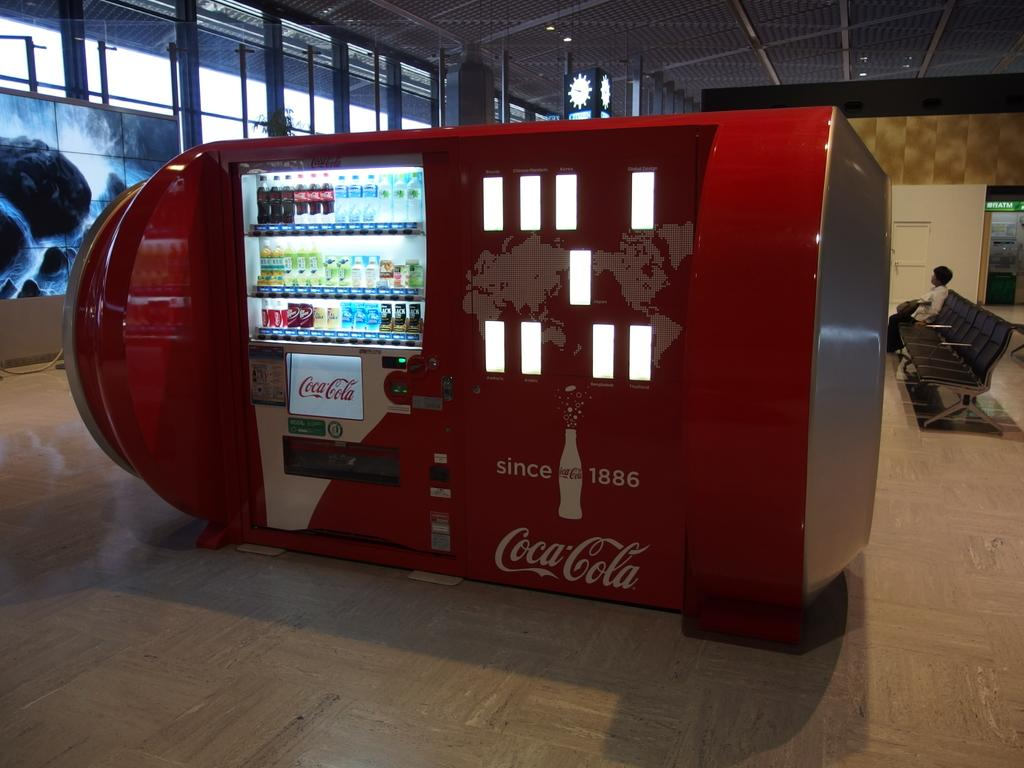What type of machine is in the image? The main subject of the image is a Coca Cola machine, which is identified by the fact that it contains bottles. We then mention other objects and elements in the image, such as the roof, chairs, poles, person, door, and screen, to provide a more comprehensive description of the scene. Absurd Question/Answer: Who won the competition between the mother and the butter in the image? There is no competition, mother, or butter present in the image. What type of butter is being used by the mother in the image? There is no butter or mother present in the image. 